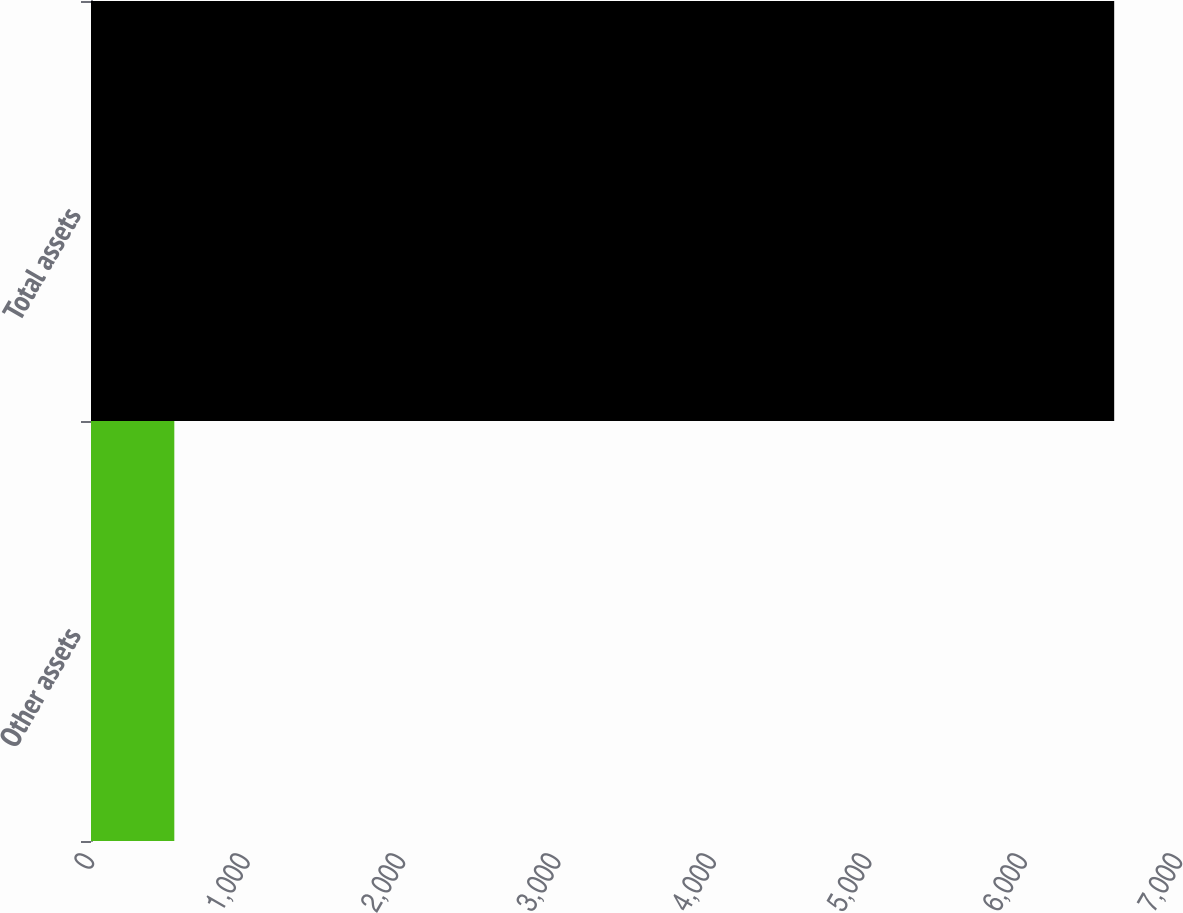Convert chart. <chart><loc_0><loc_0><loc_500><loc_500><bar_chart><fcel>Other assets<fcel>Total assets<nl><fcel>536<fcel>6583<nl></chart> 